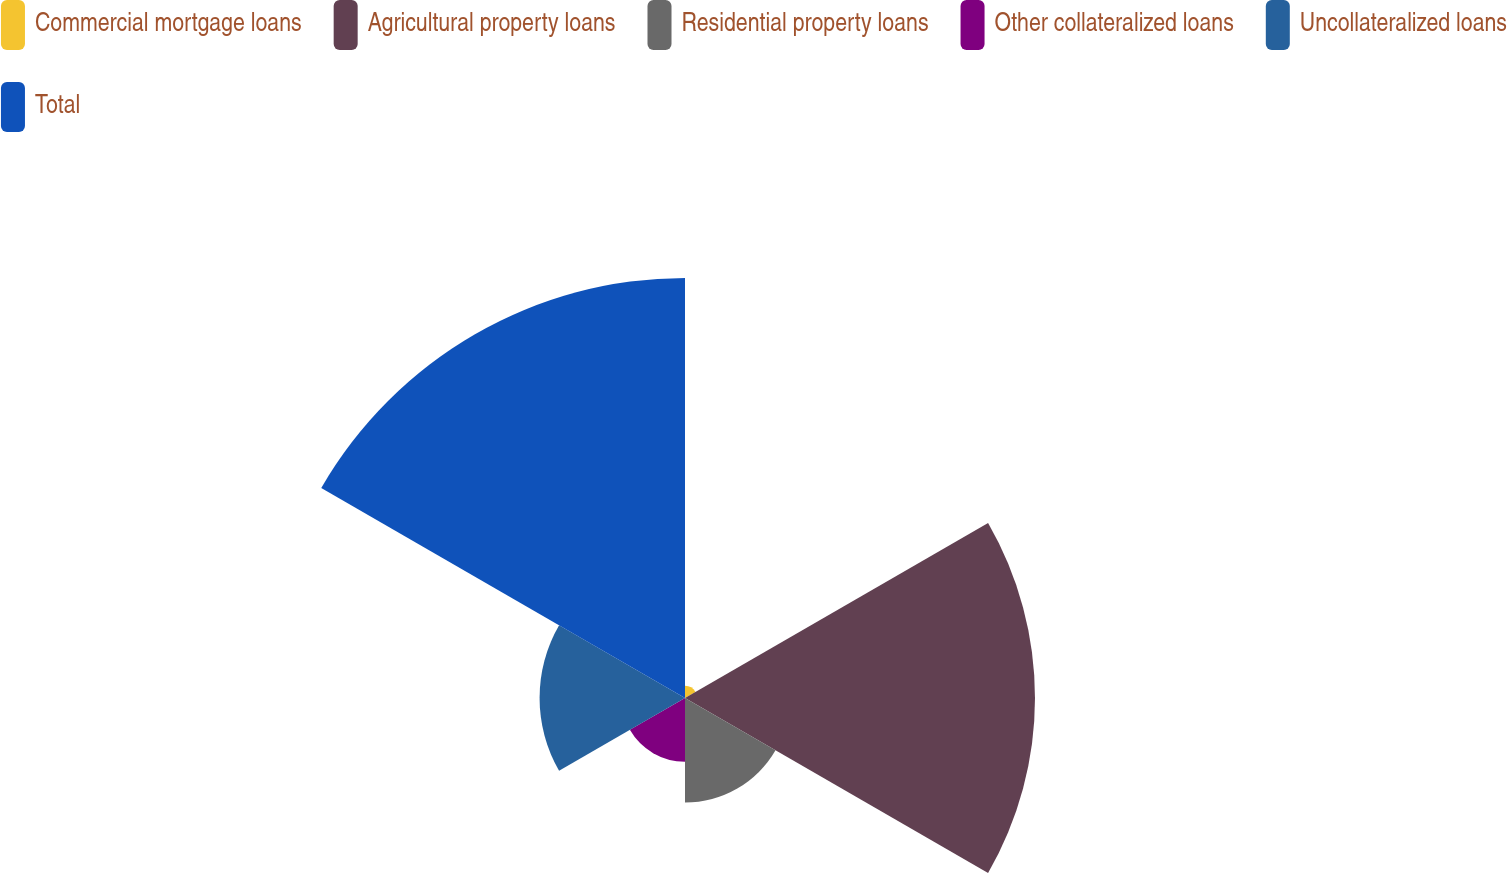Convert chart. <chart><loc_0><loc_0><loc_500><loc_500><pie_chart><fcel>Commercial mortgage loans<fcel>Agricultural property loans<fcel>Residential property loans<fcel>Other collateralized loans<fcel>Uncollateralized loans<fcel>Total<nl><fcel>1.11%<fcel>31.94%<fcel>9.54%<fcel>5.81%<fcel>13.27%<fcel>38.33%<nl></chart> 